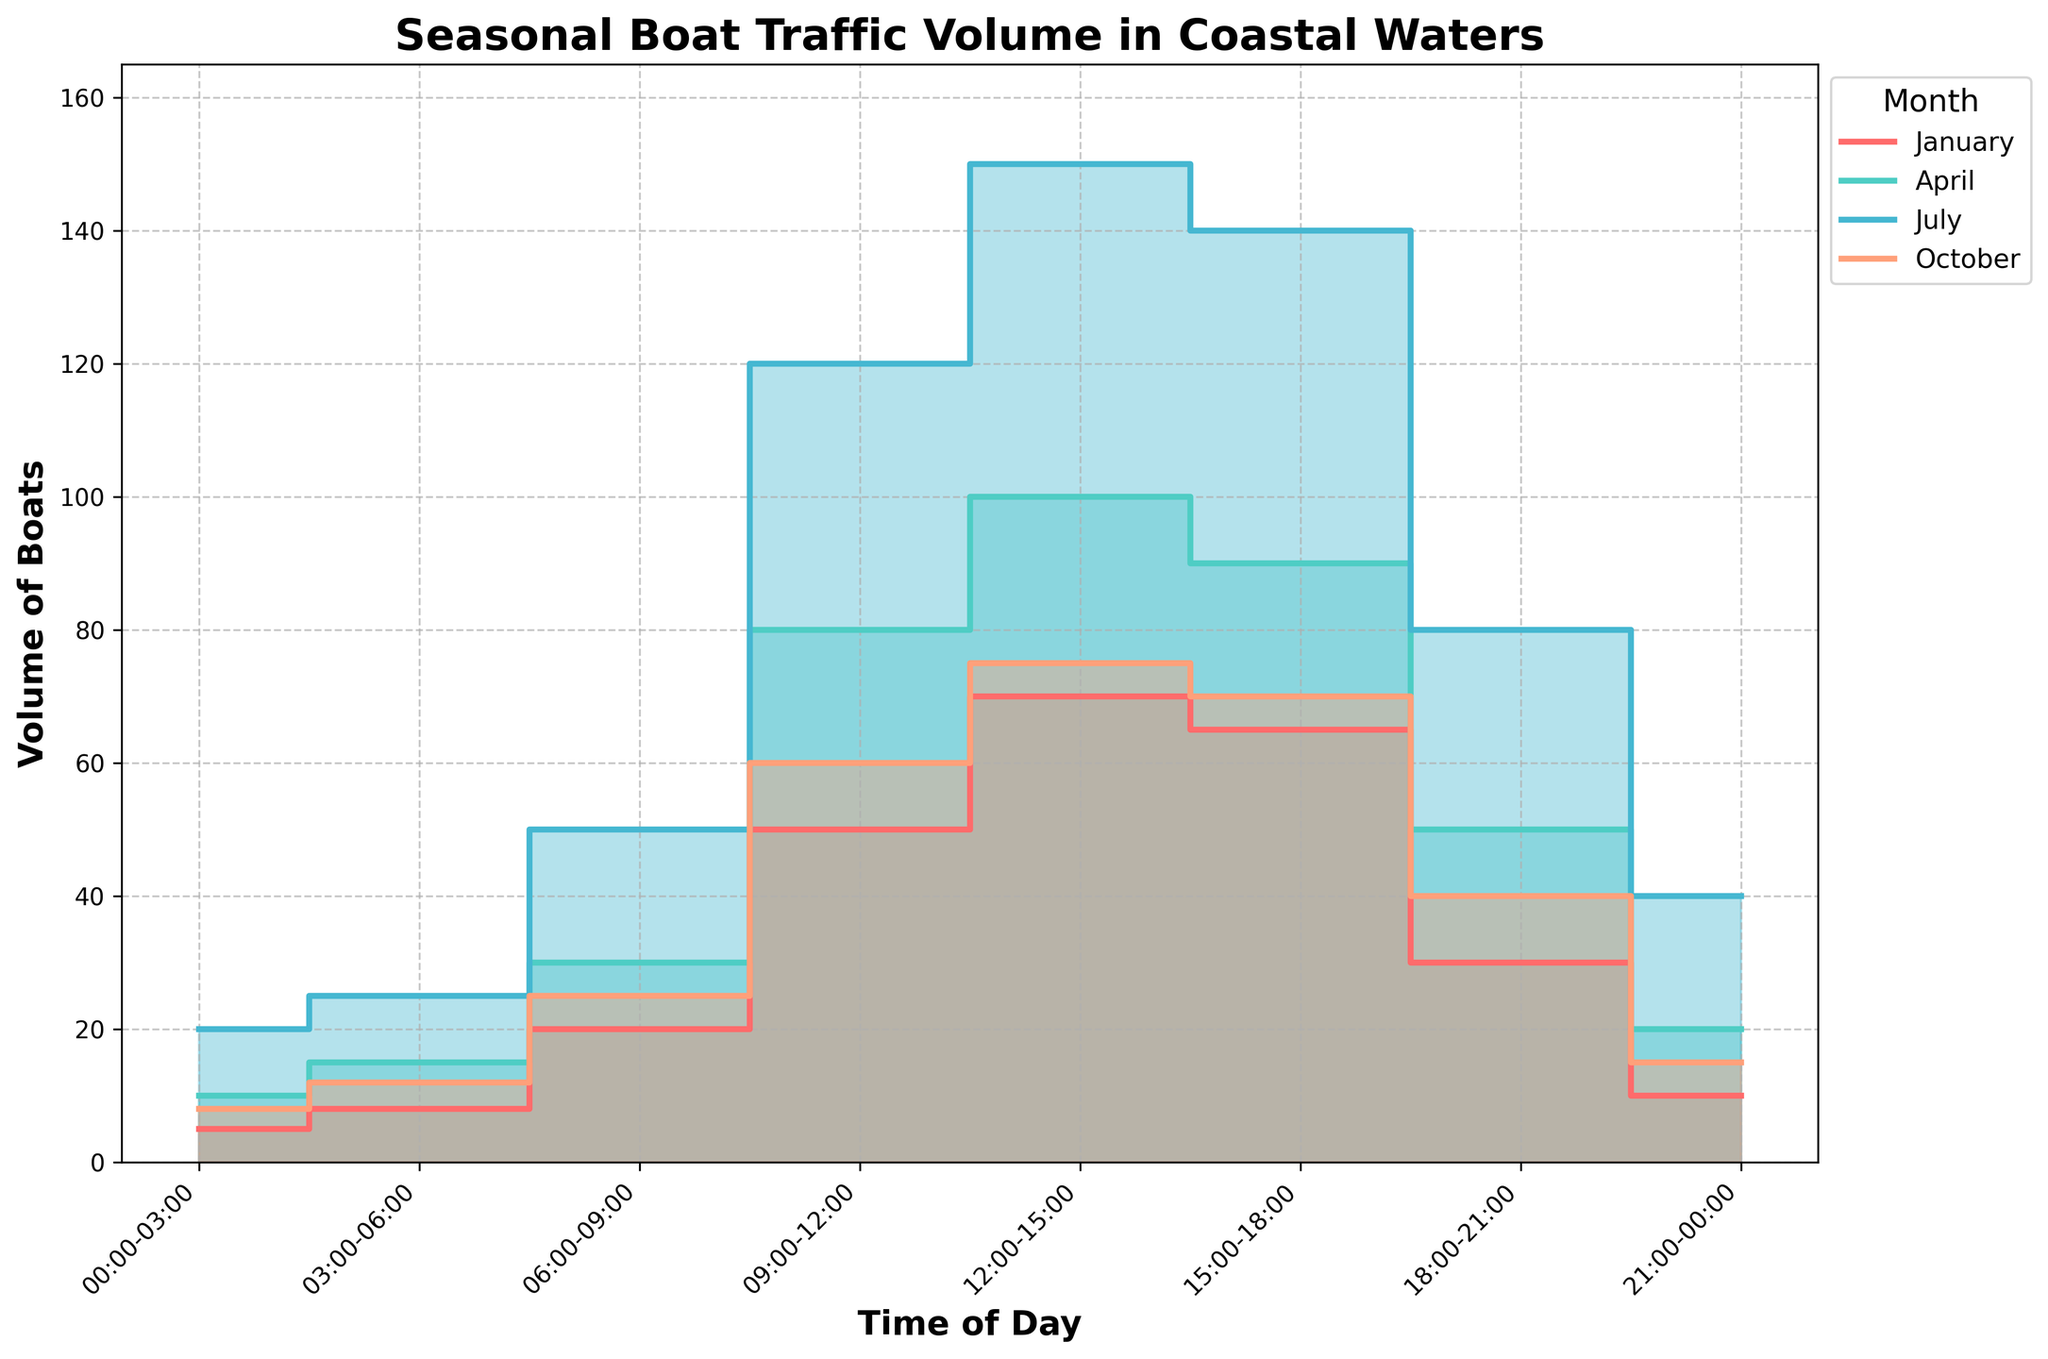What's the title of the chart? The title is typically located at the top of the chart in a larger font size, making it easy to identify. In this case, the title indicates the main subject of the figure.
Answer: Seasonal Boat Traffic Volume in Coastal Waters What are the labels on the x-axis and y-axis? Axis labels are found along the respective x and y axes of the chart and describe the data being measured along these axes.
Answer: x-axis: Time of Day, y-axis: Volume of Boats Which month has the highest peak in boat traffic volume? By examining the chart, look for the month with the highest value on the y-axis across all time intervals.
Answer: July Which time periods show the lowest and highest boat traffic in January? Identify the lowest and highest points on the step lines and the filled areas corresponding to January throughout the day's time intervals.
Answer: Lowest: 00:00-03:00, Highest: 12:00-15:00 How does the boat traffic volume at 12:00-15:00 in April compare to that in October? Find the volume of boats at 12:00-15:00 for both April and October, then directly compare the two values.
Answer: April: 100, October: 75 What is the total boat traffic volume from 00:00 to 06:00 in Miami Beach? Sum up the boat traffic volumes from 00:00-03:00 and 03:00-06:00 for July/Miami Beach to get the total for this period.
Answer: 45 Which month has the most uniform distribution of boat traffic volume throughout the day? Examine the step lines for each month to determine which month has the least variance in boat traffic volume across time periods.
Answer: January What time of day shows a noticeable drop in boat traffic volume in Miami Beach? Identify a significant decline in the step area chart for July during the different time-of-day intervals.
Answer: 18:00-21:00 Why might the boat traffic volume be higher in the middle of the day compared to early morning? Consider typical human activity patterns and the nature of boating to deduce why afternoons observe higher boat traffic.
Answer: Increased leisure activities and better weather conditions 